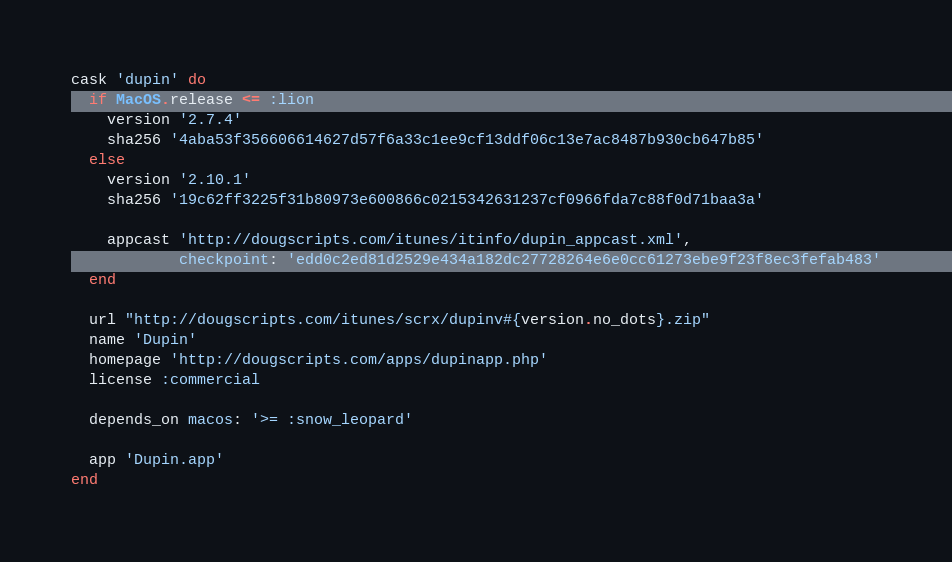Convert code to text. <code><loc_0><loc_0><loc_500><loc_500><_Ruby_>cask 'dupin' do
  if MacOS.release <= :lion
    version '2.7.4'
    sha256 '4aba53f356606614627d57f6a33c1ee9cf13ddf06c13e7ac8487b930cb647b85'
  else
    version '2.10.1'
    sha256 '19c62ff3225f31b80973e600866c0215342631237cf0966fda7c88f0d71baa3a'

    appcast 'http://dougscripts.com/itunes/itinfo/dupin_appcast.xml',
            checkpoint: 'edd0c2ed81d2529e434a182dc27728264e6e0cc61273ebe9f23f8ec3fefab483'
  end

  url "http://dougscripts.com/itunes/scrx/dupinv#{version.no_dots}.zip"
  name 'Dupin'
  homepage 'http://dougscripts.com/apps/dupinapp.php'
  license :commercial

  depends_on macos: '>= :snow_leopard'

  app 'Dupin.app'
end
</code> 